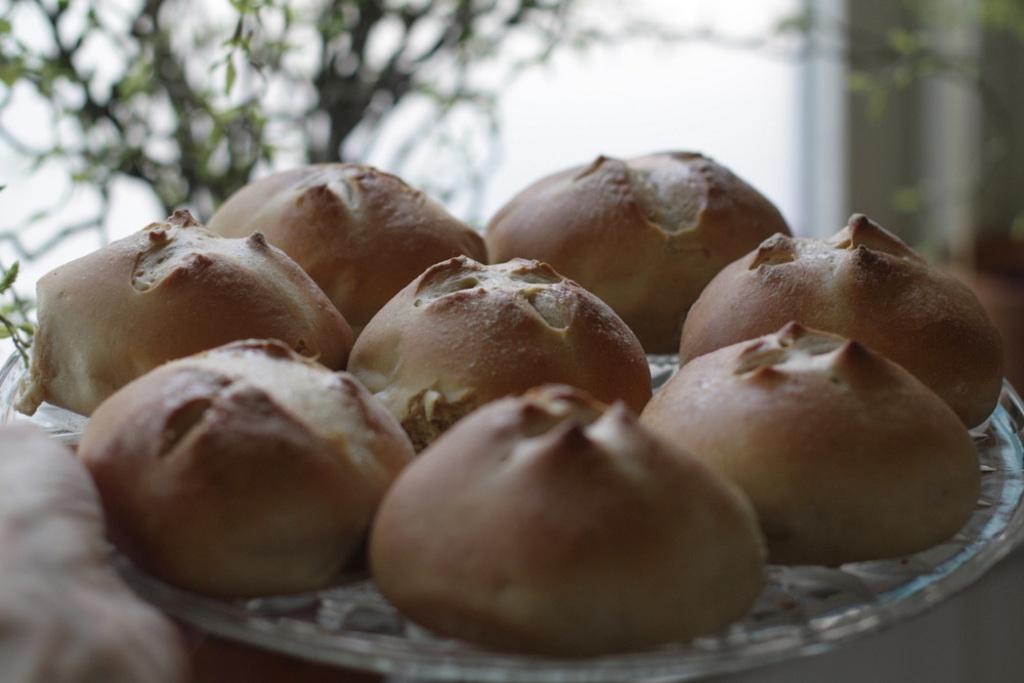What type of food item is on the plate in the image? There is a baked food item on a plate in the image. Can you describe the background of the image? There is a plant in the background of the image. How many women are present in the image? There is no mention of women in the image, so we cannot determine their presence or number. 